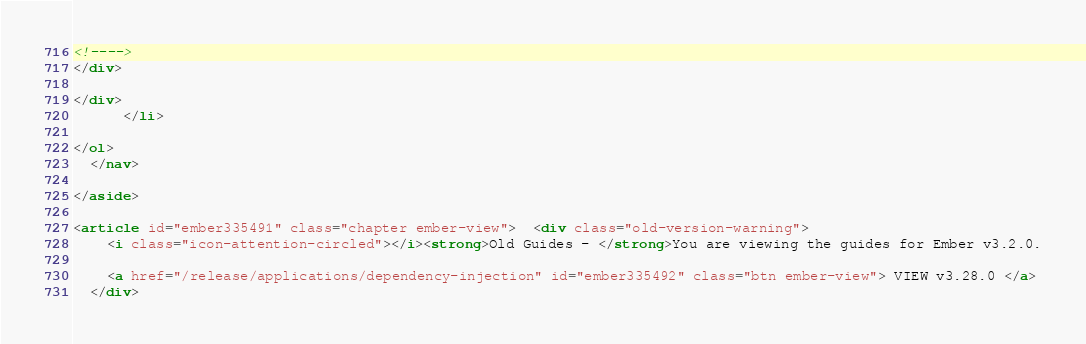Convert code to text. <code><loc_0><loc_0><loc_500><loc_500><_HTML_><!---->
</div>
        
</div>
      </li>

</ol>
  </nav>

</aside>

<article id="ember335491" class="chapter ember-view">  <div class="old-version-warning">
    <i class="icon-attention-circled"></i><strong>Old Guides - </strong>You are viewing the guides for Ember v3.2.0.

    <a href="/release/applications/dependency-injection" id="ember335492" class="btn ember-view"> VIEW v3.28.0 </a>
  </div>
</code> 